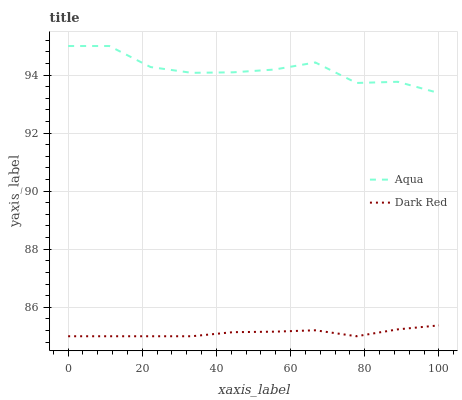Does Aqua have the minimum area under the curve?
Answer yes or no. No. Is Aqua the smoothest?
Answer yes or no. No. Does Aqua have the lowest value?
Answer yes or no. No. Is Dark Red less than Aqua?
Answer yes or no. Yes. Is Aqua greater than Dark Red?
Answer yes or no. Yes. Does Dark Red intersect Aqua?
Answer yes or no. No. 